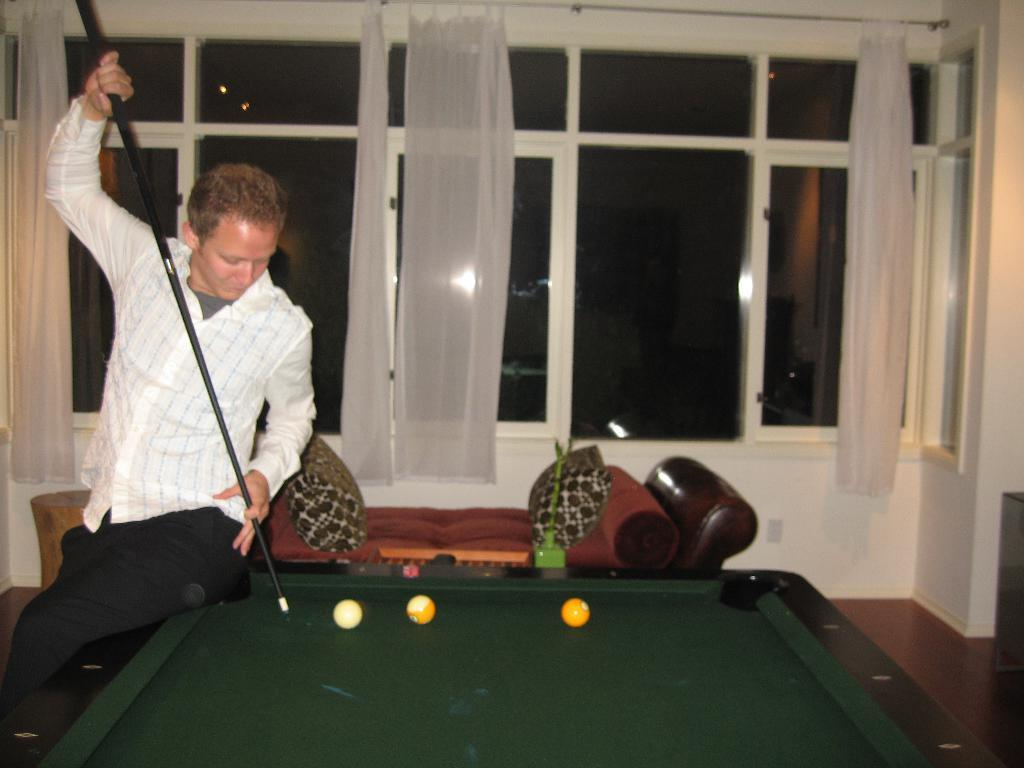What type of window coverings can be seen in the background of the image? There are windows with white curtains in the background. What can be seen on the wall in the image? There is a wall visible in the image. What activity is the man engaged in? The man is playing a snookers game. What type of seating is present in the image? There is a sofa with two pillows. What part of the room can be seen in the image? The floor is visible in the image. How many cats are playing with the snookers balls in the image? There are no cats present in the image; the man is playing a snookers game. Is there a stream visible in the image? There is no stream present in the image; it features a man playing snookers, a wall, windows with white curtains, a sofa with two pillows, and a visible floor. 